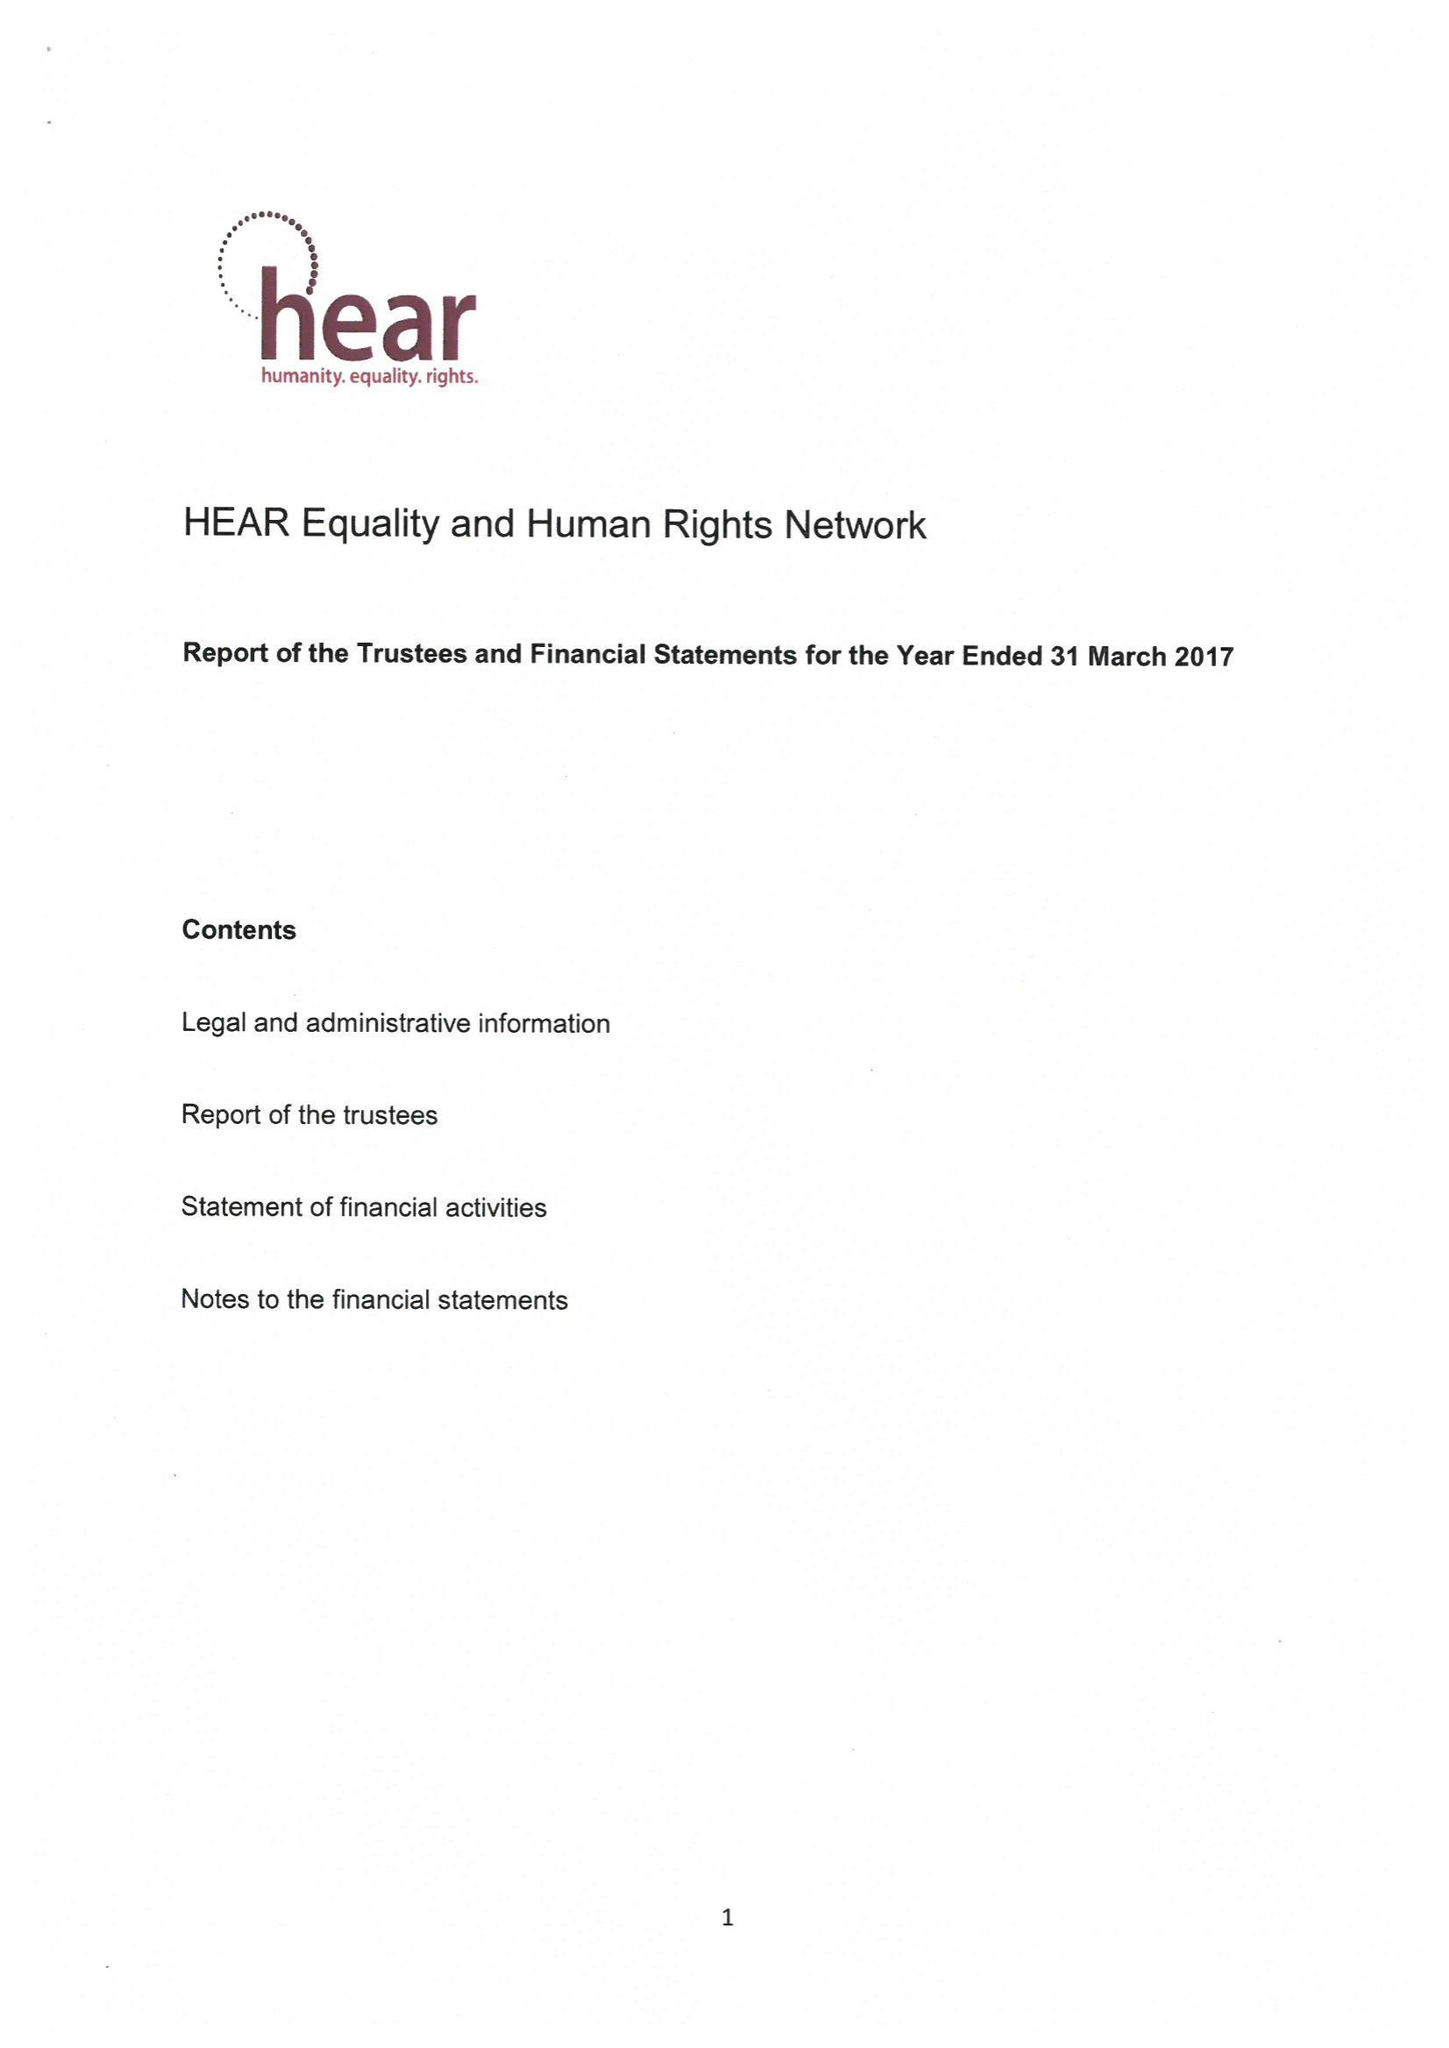What is the value for the spending_annually_in_british_pounds?
Answer the question using a single word or phrase. None 